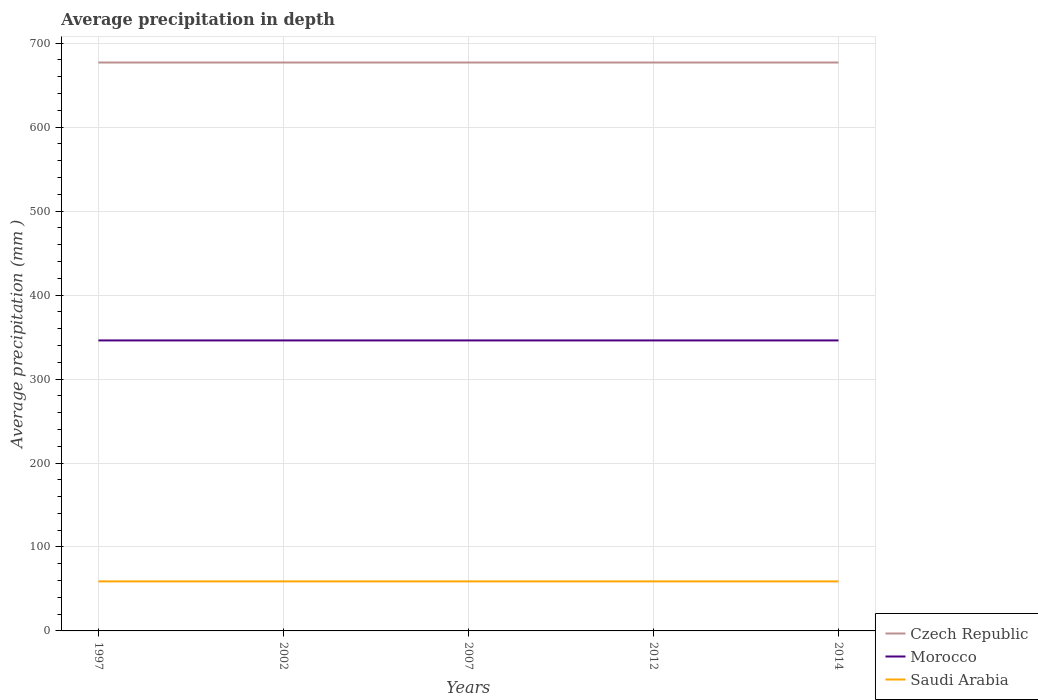Does the line corresponding to Czech Republic intersect with the line corresponding to Morocco?
Offer a terse response. No. Across all years, what is the maximum average precipitation in Morocco?
Give a very brief answer. 346. In which year was the average precipitation in Czech Republic maximum?
Offer a terse response. 1997. What is the total average precipitation in Morocco in the graph?
Provide a short and direct response. 0. What is the difference between the highest and the second highest average precipitation in Czech Republic?
Offer a very short reply. 0. Is the average precipitation in Czech Republic strictly greater than the average precipitation in Morocco over the years?
Give a very brief answer. No. Does the graph contain any zero values?
Provide a succinct answer. No. Where does the legend appear in the graph?
Ensure brevity in your answer.  Bottom right. How are the legend labels stacked?
Your answer should be compact. Vertical. What is the title of the graph?
Ensure brevity in your answer.  Average precipitation in depth. Does "Philippines" appear as one of the legend labels in the graph?
Provide a succinct answer. No. What is the label or title of the X-axis?
Give a very brief answer. Years. What is the label or title of the Y-axis?
Your answer should be very brief. Average precipitation (mm ). What is the Average precipitation (mm ) in Czech Republic in 1997?
Give a very brief answer. 677. What is the Average precipitation (mm ) in Morocco in 1997?
Give a very brief answer. 346. What is the Average precipitation (mm ) of Czech Republic in 2002?
Make the answer very short. 677. What is the Average precipitation (mm ) in Morocco in 2002?
Provide a succinct answer. 346. What is the Average precipitation (mm ) of Czech Republic in 2007?
Provide a succinct answer. 677. What is the Average precipitation (mm ) in Morocco in 2007?
Your answer should be very brief. 346. What is the Average precipitation (mm ) of Saudi Arabia in 2007?
Your answer should be very brief. 59. What is the Average precipitation (mm ) of Czech Republic in 2012?
Ensure brevity in your answer.  677. What is the Average precipitation (mm ) of Morocco in 2012?
Keep it short and to the point. 346. What is the Average precipitation (mm ) in Czech Republic in 2014?
Provide a succinct answer. 677. What is the Average precipitation (mm ) of Morocco in 2014?
Keep it short and to the point. 346. Across all years, what is the maximum Average precipitation (mm ) of Czech Republic?
Offer a terse response. 677. Across all years, what is the maximum Average precipitation (mm ) in Morocco?
Your answer should be compact. 346. Across all years, what is the minimum Average precipitation (mm ) of Czech Republic?
Your answer should be compact. 677. Across all years, what is the minimum Average precipitation (mm ) in Morocco?
Offer a very short reply. 346. What is the total Average precipitation (mm ) of Czech Republic in the graph?
Your answer should be compact. 3385. What is the total Average precipitation (mm ) in Morocco in the graph?
Provide a succinct answer. 1730. What is the total Average precipitation (mm ) in Saudi Arabia in the graph?
Give a very brief answer. 295. What is the difference between the Average precipitation (mm ) of Czech Republic in 1997 and that in 2002?
Provide a short and direct response. 0. What is the difference between the Average precipitation (mm ) in Morocco in 1997 and that in 2002?
Your response must be concise. 0. What is the difference between the Average precipitation (mm ) of Saudi Arabia in 1997 and that in 2007?
Make the answer very short. 0. What is the difference between the Average precipitation (mm ) in Czech Republic in 1997 and that in 2012?
Your answer should be very brief. 0. What is the difference between the Average precipitation (mm ) in Morocco in 1997 and that in 2012?
Offer a very short reply. 0. What is the difference between the Average precipitation (mm ) in Czech Republic in 1997 and that in 2014?
Offer a terse response. 0. What is the difference between the Average precipitation (mm ) of Morocco in 1997 and that in 2014?
Offer a very short reply. 0. What is the difference between the Average precipitation (mm ) of Saudi Arabia in 1997 and that in 2014?
Your response must be concise. 0. What is the difference between the Average precipitation (mm ) in Morocco in 2002 and that in 2014?
Offer a terse response. 0. What is the difference between the Average precipitation (mm ) of Saudi Arabia in 2007 and that in 2012?
Your answer should be compact. 0. What is the difference between the Average precipitation (mm ) in Morocco in 2007 and that in 2014?
Provide a short and direct response. 0. What is the difference between the Average precipitation (mm ) of Saudi Arabia in 2007 and that in 2014?
Offer a very short reply. 0. What is the difference between the Average precipitation (mm ) in Saudi Arabia in 2012 and that in 2014?
Offer a very short reply. 0. What is the difference between the Average precipitation (mm ) of Czech Republic in 1997 and the Average precipitation (mm ) of Morocco in 2002?
Offer a very short reply. 331. What is the difference between the Average precipitation (mm ) in Czech Republic in 1997 and the Average precipitation (mm ) in Saudi Arabia in 2002?
Your response must be concise. 618. What is the difference between the Average precipitation (mm ) of Morocco in 1997 and the Average precipitation (mm ) of Saudi Arabia in 2002?
Offer a very short reply. 287. What is the difference between the Average precipitation (mm ) of Czech Republic in 1997 and the Average precipitation (mm ) of Morocco in 2007?
Provide a short and direct response. 331. What is the difference between the Average precipitation (mm ) of Czech Republic in 1997 and the Average precipitation (mm ) of Saudi Arabia in 2007?
Provide a short and direct response. 618. What is the difference between the Average precipitation (mm ) in Morocco in 1997 and the Average precipitation (mm ) in Saudi Arabia in 2007?
Ensure brevity in your answer.  287. What is the difference between the Average precipitation (mm ) of Czech Republic in 1997 and the Average precipitation (mm ) of Morocco in 2012?
Your answer should be compact. 331. What is the difference between the Average precipitation (mm ) in Czech Republic in 1997 and the Average precipitation (mm ) in Saudi Arabia in 2012?
Offer a very short reply. 618. What is the difference between the Average precipitation (mm ) in Morocco in 1997 and the Average precipitation (mm ) in Saudi Arabia in 2012?
Your answer should be compact. 287. What is the difference between the Average precipitation (mm ) in Czech Republic in 1997 and the Average precipitation (mm ) in Morocco in 2014?
Offer a terse response. 331. What is the difference between the Average precipitation (mm ) of Czech Republic in 1997 and the Average precipitation (mm ) of Saudi Arabia in 2014?
Make the answer very short. 618. What is the difference between the Average precipitation (mm ) in Morocco in 1997 and the Average precipitation (mm ) in Saudi Arabia in 2014?
Keep it short and to the point. 287. What is the difference between the Average precipitation (mm ) of Czech Republic in 2002 and the Average precipitation (mm ) of Morocco in 2007?
Keep it short and to the point. 331. What is the difference between the Average precipitation (mm ) of Czech Republic in 2002 and the Average precipitation (mm ) of Saudi Arabia in 2007?
Ensure brevity in your answer.  618. What is the difference between the Average precipitation (mm ) in Morocco in 2002 and the Average precipitation (mm ) in Saudi Arabia in 2007?
Keep it short and to the point. 287. What is the difference between the Average precipitation (mm ) in Czech Republic in 2002 and the Average precipitation (mm ) in Morocco in 2012?
Offer a terse response. 331. What is the difference between the Average precipitation (mm ) of Czech Republic in 2002 and the Average precipitation (mm ) of Saudi Arabia in 2012?
Keep it short and to the point. 618. What is the difference between the Average precipitation (mm ) in Morocco in 2002 and the Average precipitation (mm ) in Saudi Arabia in 2012?
Ensure brevity in your answer.  287. What is the difference between the Average precipitation (mm ) of Czech Republic in 2002 and the Average precipitation (mm ) of Morocco in 2014?
Offer a very short reply. 331. What is the difference between the Average precipitation (mm ) of Czech Republic in 2002 and the Average precipitation (mm ) of Saudi Arabia in 2014?
Your response must be concise. 618. What is the difference between the Average precipitation (mm ) in Morocco in 2002 and the Average precipitation (mm ) in Saudi Arabia in 2014?
Your answer should be very brief. 287. What is the difference between the Average precipitation (mm ) in Czech Republic in 2007 and the Average precipitation (mm ) in Morocco in 2012?
Your response must be concise. 331. What is the difference between the Average precipitation (mm ) of Czech Republic in 2007 and the Average precipitation (mm ) of Saudi Arabia in 2012?
Offer a very short reply. 618. What is the difference between the Average precipitation (mm ) in Morocco in 2007 and the Average precipitation (mm ) in Saudi Arabia in 2012?
Offer a terse response. 287. What is the difference between the Average precipitation (mm ) of Czech Republic in 2007 and the Average precipitation (mm ) of Morocco in 2014?
Make the answer very short. 331. What is the difference between the Average precipitation (mm ) of Czech Republic in 2007 and the Average precipitation (mm ) of Saudi Arabia in 2014?
Make the answer very short. 618. What is the difference between the Average precipitation (mm ) in Morocco in 2007 and the Average precipitation (mm ) in Saudi Arabia in 2014?
Keep it short and to the point. 287. What is the difference between the Average precipitation (mm ) in Czech Republic in 2012 and the Average precipitation (mm ) in Morocco in 2014?
Offer a terse response. 331. What is the difference between the Average precipitation (mm ) of Czech Republic in 2012 and the Average precipitation (mm ) of Saudi Arabia in 2014?
Provide a succinct answer. 618. What is the difference between the Average precipitation (mm ) in Morocco in 2012 and the Average precipitation (mm ) in Saudi Arabia in 2014?
Make the answer very short. 287. What is the average Average precipitation (mm ) in Czech Republic per year?
Offer a terse response. 677. What is the average Average precipitation (mm ) in Morocco per year?
Your answer should be compact. 346. What is the average Average precipitation (mm ) of Saudi Arabia per year?
Give a very brief answer. 59. In the year 1997, what is the difference between the Average precipitation (mm ) in Czech Republic and Average precipitation (mm ) in Morocco?
Provide a short and direct response. 331. In the year 1997, what is the difference between the Average precipitation (mm ) of Czech Republic and Average precipitation (mm ) of Saudi Arabia?
Offer a very short reply. 618. In the year 1997, what is the difference between the Average precipitation (mm ) of Morocco and Average precipitation (mm ) of Saudi Arabia?
Ensure brevity in your answer.  287. In the year 2002, what is the difference between the Average precipitation (mm ) of Czech Republic and Average precipitation (mm ) of Morocco?
Provide a succinct answer. 331. In the year 2002, what is the difference between the Average precipitation (mm ) in Czech Republic and Average precipitation (mm ) in Saudi Arabia?
Ensure brevity in your answer.  618. In the year 2002, what is the difference between the Average precipitation (mm ) in Morocco and Average precipitation (mm ) in Saudi Arabia?
Offer a very short reply. 287. In the year 2007, what is the difference between the Average precipitation (mm ) of Czech Republic and Average precipitation (mm ) of Morocco?
Give a very brief answer. 331. In the year 2007, what is the difference between the Average precipitation (mm ) of Czech Republic and Average precipitation (mm ) of Saudi Arabia?
Offer a terse response. 618. In the year 2007, what is the difference between the Average precipitation (mm ) of Morocco and Average precipitation (mm ) of Saudi Arabia?
Keep it short and to the point. 287. In the year 2012, what is the difference between the Average precipitation (mm ) in Czech Republic and Average precipitation (mm ) in Morocco?
Make the answer very short. 331. In the year 2012, what is the difference between the Average precipitation (mm ) in Czech Republic and Average precipitation (mm ) in Saudi Arabia?
Your answer should be compact. 618. In the year 2012, what is the difference between the Average precipitation (mm ) of Morocco and Average precipitation (mm ) of Saudi Arabia?
Make the answer very short. 287. In the year 2014, what is the difference between the Average precipitation (mm ) in Czech Republic and Average precipitation (mm ) in Morocco?
Offer a terse response. 331. In the year 2014, what is the difference between the Average precipitation (mm ) of Czech Republic and Average precipitation (mm ) of Saudi Arabia?
Make the answer very short. 618. In the year 2014, what is the difference between the Average precipitation (mm ) of Morocco and Average precipitation (mm ) of Saudi Arabia?
Provide a short and direct response. 287. What is the ratio of the Average precipitation (mm ) in Czech Republic in 1997 to that in 2002?
Offer a very short reply. 1. What is the ratio of the Average precipitation (mm ) in Saudi Arabia in 1997 to that in 2002?
Your answer should be very brief. 1. What is the ratio of the Average precipitation (mm ) in Saudi Arabia in 1997 to that in 2007?
Your answer should be compact. 1. What is the ratio of the Average precipitation (mm ) of Saudi Arabia in 1997 to that in 2012?
Make the answer very short. 1. What is the ratio of the Average precipitation (mm ) in Czech Republic in 1997 to that in 2014?
Offer a very short reply. 1. What is the ratio of the Average precipitation (mm ) of Morocco in 1997 to that in 2014?
Keep it short and to the point. 1. What is the ratio of the Average precipitation (mm ) of Czech Republic in 2002 to that in 2012?
Make the answer very short. 1. What is the ratio of the Average precipitation (mm ) of Morocco in 2002 to that in 2012?
Provide a succinct answer. 1. What is the ratio of the Average precipitation (mm ) in Saudi Arabia in 2002 to that in 2014?
Give a very brief answer. 1. What is the ratio of the Average precipitation (mm ) of Saudi Arabia in 2007 to that in 2012?
Give a very brief answer. 1. What is the ratio of the Average precipitation (mm ) in Czech Republic in 2012 to that in 2014?
Your response must be concise. 1. What is the ratio of the Average precipitation (mm ) in Saudi Arabia in 2012 to that in 2014?
Provide a succinct answer. 1. What is the difference between the highest and the lowest Average precipitation (mm ) in Saudi Arabia?
Provide a short and direct response. 0. 